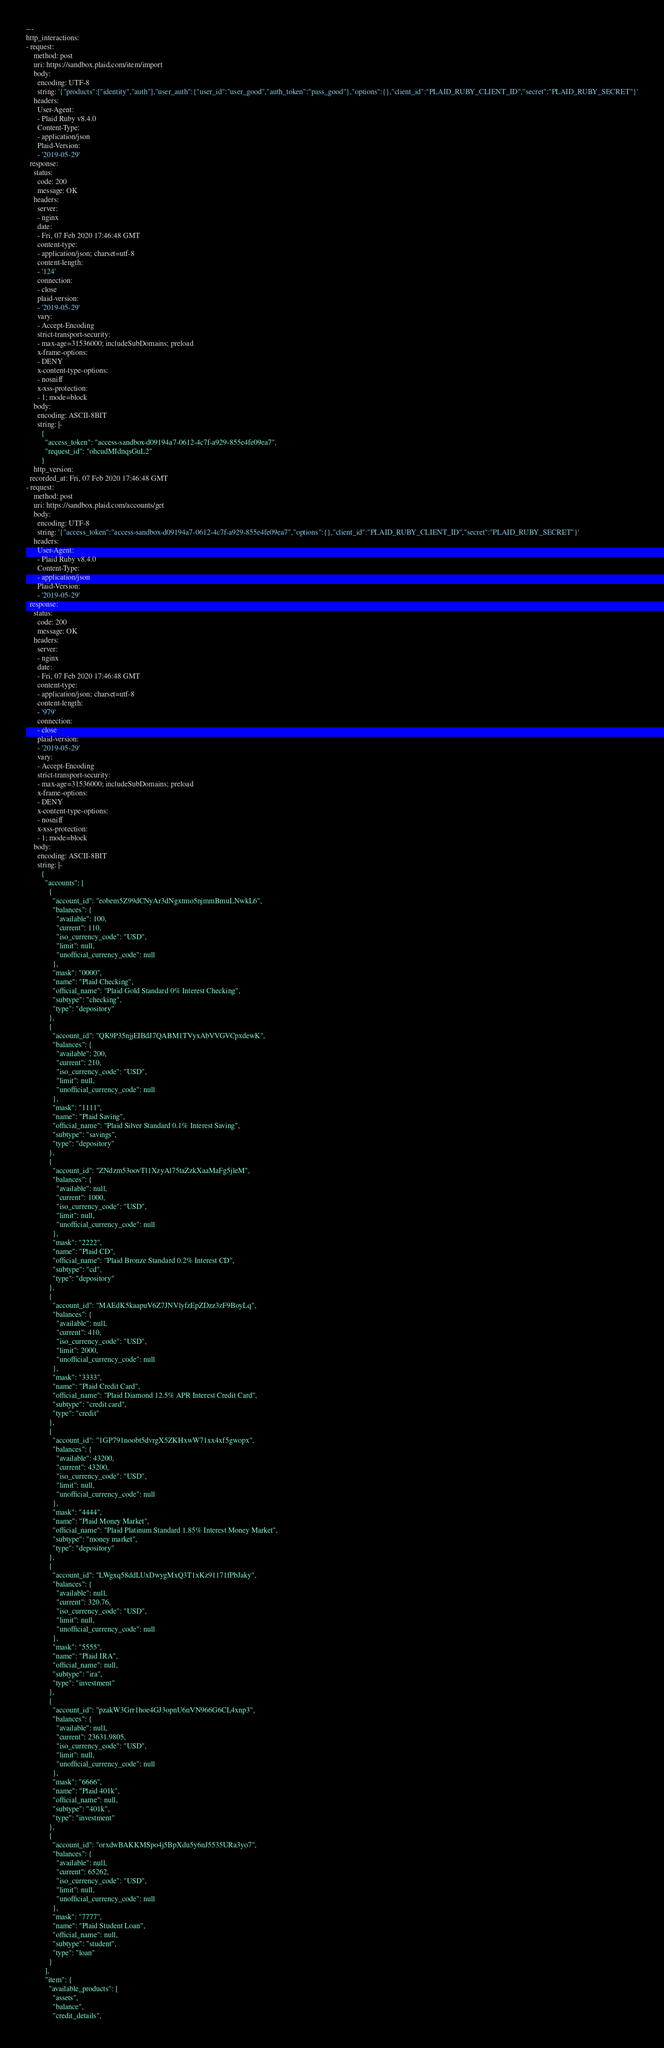<code> <loc_0><loc_0><loc_500><loc_500><_YAML_>---
http_interactions:
- request:
    method: post
    uri: https://sandbox.plaid.com/item/import
    body:
      encoding: UTF-8
      string: '{"products":["identity","auth"],"user_auth":{"user_id":"user_good","auth_token":"pass_good"},"options":{},"client_id":"PLAID_RUBY_CLIENT_ID","secret":"PLAID_RUBY_SECRET"}'
    headers:
      User-Agent:
      - Plaid Ruby v8.4.0
      Content-Type:
      - application/json
      Plaid-Version:
      - '2019-05-29'
  response:
    status:
      code: 200
      message: OK
    headers:
      server:
      - nginx
      date:
      - Fri, 07 Feb 2020 17:46:48 GMT
      content-type:
      - application/json; charset=utf-8
      content-length:
      - '124'
      connection:
      - close
      plaid-version:
      - '2019-05-29'
      vary:
      - Accept-Encoding
      strict-transport-security:
      - max-age=31536000; includeSubDomains; preload
      x-frame-options:
      - DENY
      x-content-type-options:
      - nosniff
      x-xss-protection:
      - 1; mode=block
    body:
      encoding: ASCII-8BIT
      string: |-
        {
          "access_token": "access-sandbox-d09194a7-0612-4c7f-a929-855e4fe09ea7",
          "request_id": "ohcudMIdnqsGuL2"
        }
    http_version: 
  recorded_at: Fri, 07 Feb 2020 17:46:48 GMT
- request:
    method: post
    uri: https://sandbox.plaid.com/accounts/get
    body:
      encoding: UTF-8
      string: '{"access_token":"access-sandbox-d09194a7-0612-4c7f-a929-855e4fe09ea7","options":{},"client_id":"PLAID_RUBY_CLIENT_ID","secret":"PLAID_RUBY_SECRET"}'
    headers:
      User-Agent:
      - Plaid Ruby v8.4.0
      Content-Type:
      - application/json
      Plaid-Version:
      - '2019-05-29'
  response:
    status:
      code: 200
      message: OK
    headers:
      server:
      - nginx
      date:
      - Fri, 07 Feb 2020 17:46:48 GMT
      content-type:
      - application/json; charset=utf-8
      content-length:
      - '979'
      connection:
      - close
      plaid-version:
      - '2019-05-29'
      vary:
      - Accept-Encoding
      strict-transport-security:
      - max-age=31536000; includeSubDomains; preload
      x-frame-options:
      - DENY
      x-content-type-options:
      - nosniff
      x-xss-protection:
      - 1; mode=block
    body:
      encoding: ASCII-8BIT
      string: |-
        {
          "accounts": [
            {
              "account_id": "eobem5Z99dCNyAr3dNgxtmo5njmmBmuLNwkL6",
              "balances": {
                "available": 100,
                "current": 110,
                "iso_currency_code": "USD",
                "limit": null,
                "unofficial_currency_code": null
              },
              "mask": "0000",
              "name": "Plaid Checking",
              "official_name": "Plaid Gold Standard 0% Interest Checking",
              "subtype": "checking",
              "type": "depository"
            },
            {
              "account_id": "QK9P35njjEIBdJ7QABM1TVyxAbVVGVCpxdewK",
              "balances": {
                "available": 200,
                "current": 210,
                "iso_currency_code": "USD",
                "limit": null,
                "unofficial_currency_code": null
              },
              "mask": "1111",
              "name": "Plaid Saving",
              "official_name": "Plaid Silver Standard 0.1% Interest Saving",
              "subtype": "savings",
              "type": "depository"
            },
            {
              "account_id": "ZNdzm53oovTl1XzyAl75taZzkXaaMaFg5jleM",
              "balances": {
                "available": null,
                "current": 1000,
                "iso_currency_code": "USD",
                "limit": null,
                "unofficial_currency_code": null
              },
              "mask": "2222",
              "name": "Plaid CD",
              "official_name": "Plaid Bronze Standard 0.2% Interest CD",
              "subtype": "cd",
              "type": "depository"
            },
            {
              "account_id": "MAEdK5kaapuV6Z7JNVlyfzEpZDzz3zF9BoyLq",
              "balances": {
                "available": null,
                "current": 410,
                "iso_currency_code": "USD",
                "limit": 2000,
                "unofficial_currency_code": null
              },
              "mask": "3333",
              "name": "Plaid Credit Card",
              "official_name": "Plaid Diamond 12.5% APR Interest Credit Card",
              "subtype": "credit card",
              "type": "credit"
            },
            {
              "account_id": "1GP791noobt5dvrgX5ZKHxwW71xx4xf5gwopx",
              "balances": {
                "available": 43200,
                "current": 43200,
                "iso_currency_code": "USD",
                "limit": null,
                "unofficial_currency_code": null
              },
              "mask": "4444",
              "name": "Plaid Money Market",
              "official_name": "Plaid Platinum Standard 1.85% Interest Money Market",
              "subtype": "money market",
              "type": "depository"
            },
            {
              "account_id": "LWgxq58ddLUxDwygMxQ3T1xKz91171fPbJaky",
              "balances": {
                "available": null,
                "current": 320.76,
                "iso_currency_code": "USD",
                "limit": null,
                "unofficial_currency_code": null
              },
              "mask": "5555",
              "name": "Plaid IRA",
              "official_name": null,
              "subtype": "ira",
              "type": "investment"
            },
            {
              "account_id": "pzakW3Grr1hoe4GJ3opnU6nVN966G6CL4xnp3",
              "balances": {
                "available": null,
                "current": 23631.9805,
                "iso_currency_code": "USD",
                "limit": null,
                "unofficial_currency_code": null
              },
              "mask": "6666",
              "name": "Plaid 401k",
              "official_name": null,
              "subtype": "401k",
              "type": "investment"
            },
            {
              "account_id": "orxdwBAKKMSpo4j5BpXdu5y6nJ5535URa3yo7",
              "balances": {
                "available": null,
                "current": 65262,
                "iso_currency_code": "USD",
                "limit": null,
                "unofficial_currency_code": null
              },
              "mask": "7777",
              "name": "Plaid Student Loan",
              "official_name": null,
              "subtype": "student",
              "type": "loan"
            }
          ],
          "item": {
            "available_products": [
              "assets",
              "balance",
              "credit_details",</code> 